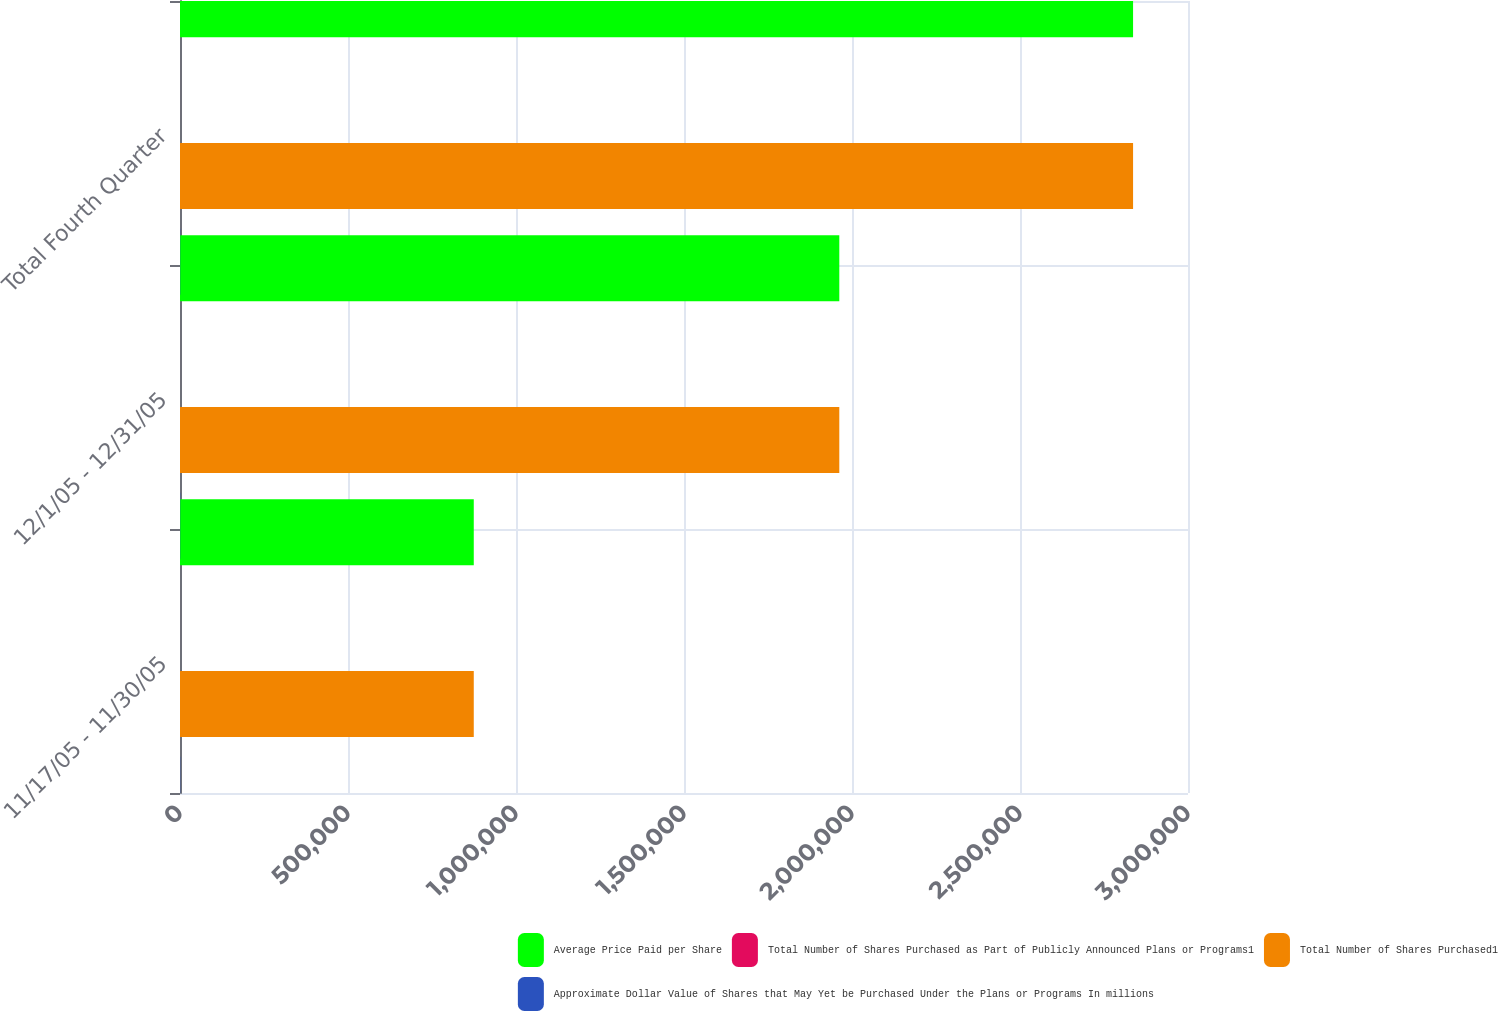<chart> <loc_0><loc_0><loc_500><loc_500><stacked_bar_chart><ecel><fcel>11/17/05 - 11/30/05<fcel>12/1/05 - 12/31/05<fcel>Total Fourth Quarter<nl><fcel>Average Price Paid per Share<fcel>874306<fcel>1.96221e+06<fcel>2.83652e+06<nl><fcel>Total Number of Shares Purchased as Part of Publicly Announced Plans or Programs1<fcel>26.25<fcel>27.29<fcel>26.97<nl><fcel>Total Number of Shares Purchased1<fcel>874306<fcel>1.96221e+06<fcel>2.83652e+06<nl><fcel>Approximate Dollar Value of Shares that May Yet be Purchased Under the Plans or Programs In millions<fcel>727<fcel>673.4<fcel>673.4<nl></chart> 